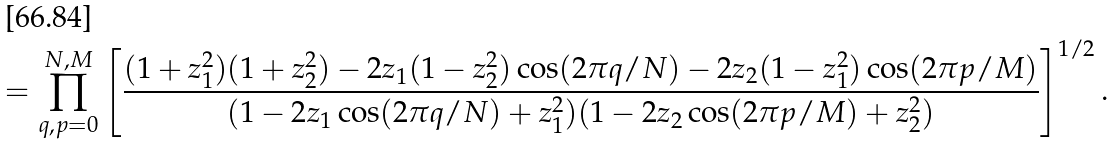<formula> <loc_0><loc_0><loc_500><loc_500>= \prod _ { q , p = 0 } ^ { N , M } \left [ \frac { ( 1 + z _ { 1 } ^ { 2 } ) ( 1 + z _ { 2 } ^ { 2 } ) - 2 z _ { 1 } ( 1 - z _ { 2 } ^ { 2 } ) \cos ( 2 \pi q / N ) - 2 z _ { 2 } ( 1 - z _ { 1 } ^ { 2 } ) \cos ( 2 \pi p / M ) } { ( 1 - 2 z _ { 1 } \cos ( 2 \pi q / N ) + z _ { 1 } ^ { 2 } ) ( 1 - 2 z _ { 2 } \cos ( 2 \pi p / M ) + z _ { 2 } ^ { 2 } ) } \right ] ^ { 1 / 2 } .</formula> 